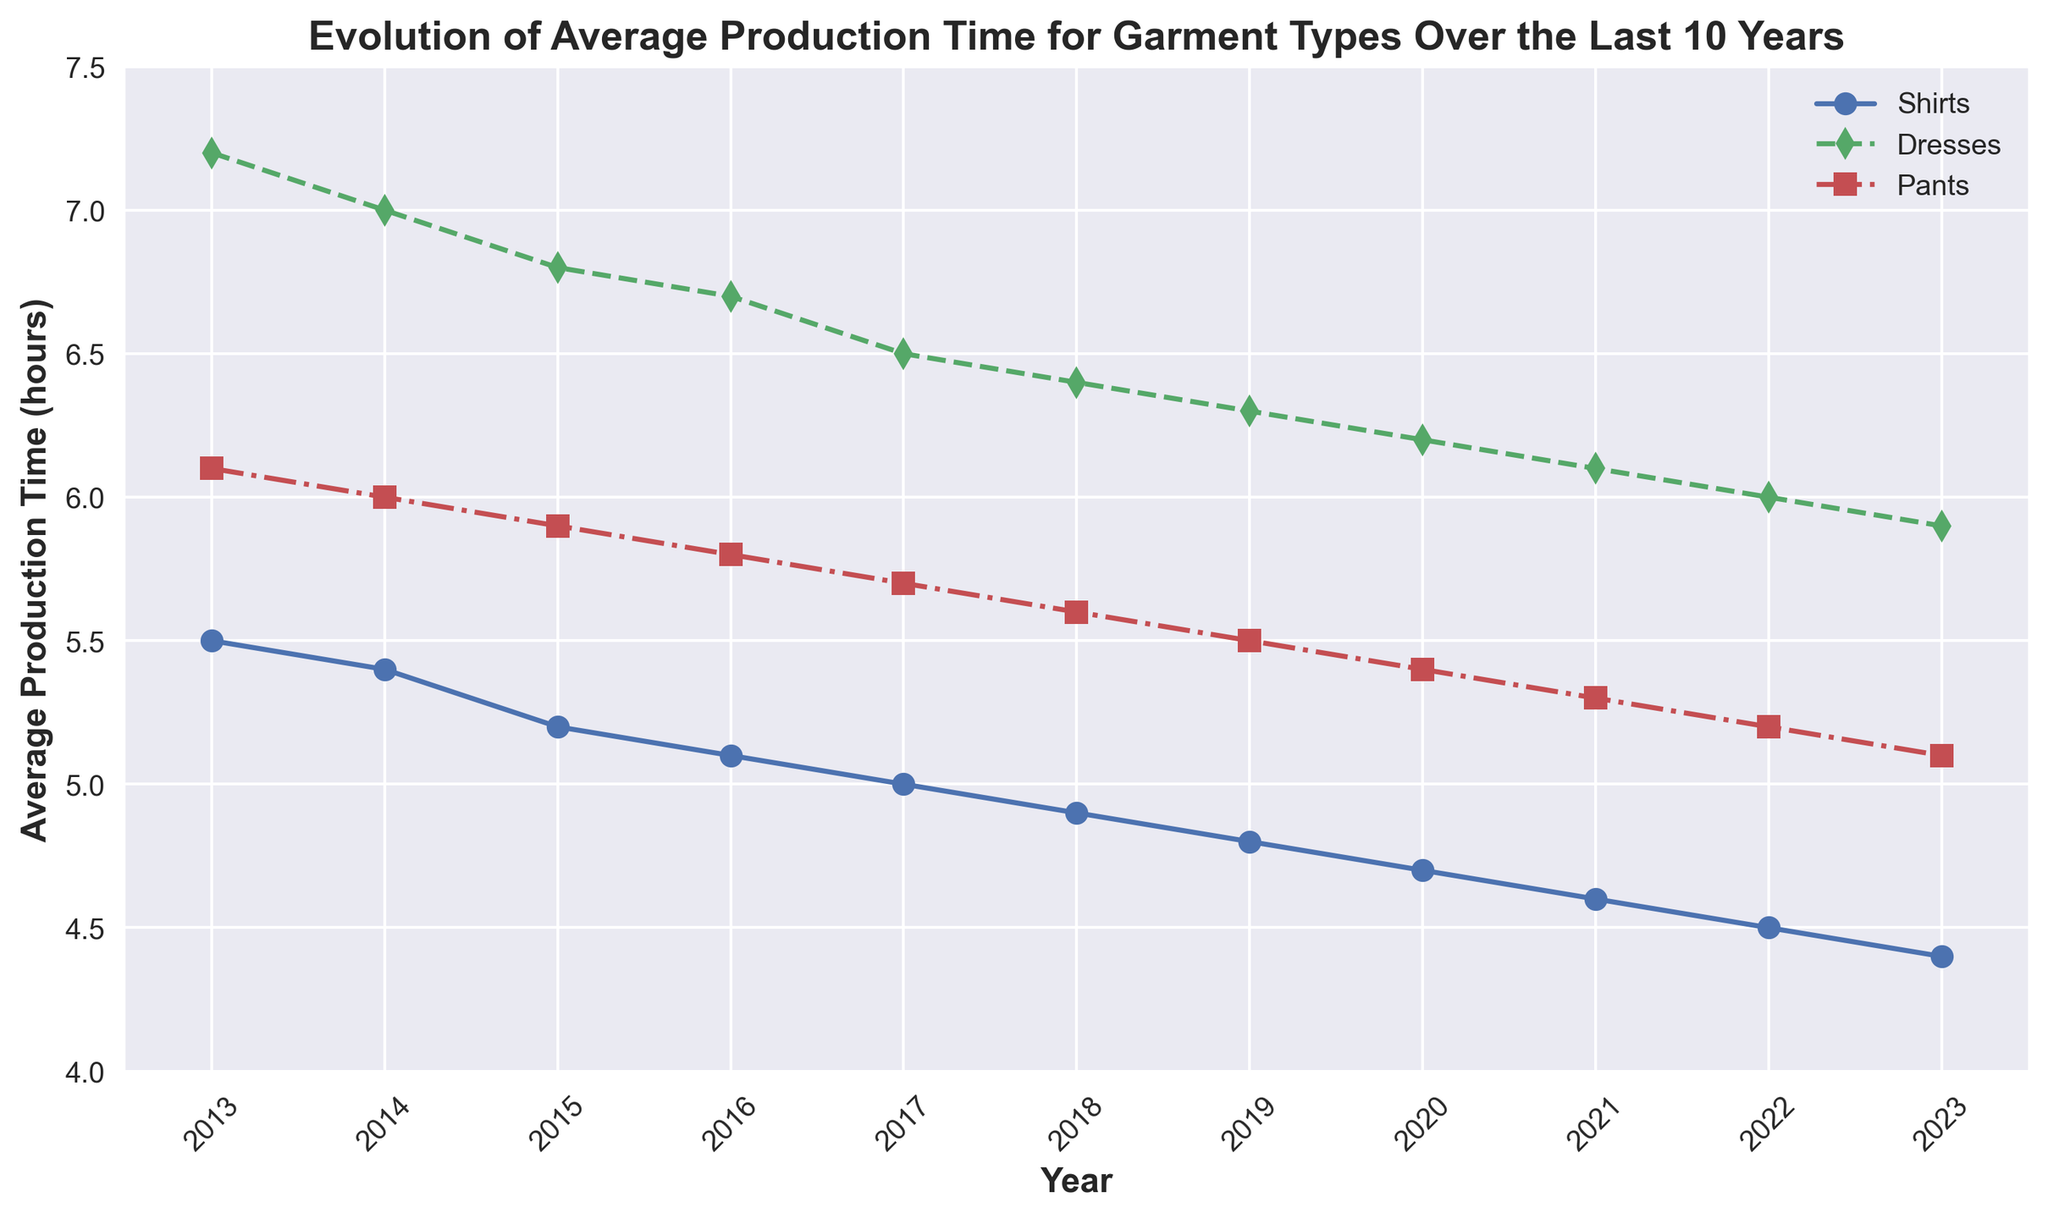What is the trend in the average production time for shirts over the last 10 years? The graph shows a downward trend for shirts' production time from 5.5 hours in 2013 to 4.4 hours in 2023. This indicates an overall decrease in production time over the period.
Answer: Decreasing How does the production time for dresses in 2023 compare to that for pants in 2021? The production time for dresses in 2023 is 5.9 hours, while for pants in 2021, it is 5.3 hours. Since 5.9 is greater than 5.3, the production time for dresses in 2023 is higher.
Answer: Dresses in 2023 are higher What is the difference in production times between pants in 2015 and pants in 2023? In 2015, the production time for pants was 5.9 hours, and in 2023, it was 5.1 hours. The difference is 5.9 - 5.1 = 0.8 hours.
Answer: 0.8 hours Which garment type had the highest average production time in 2017? The graph shows that in 2017, dresses had the highest production time at 6.5 hours, compared to shirts at 5.0 hours and pants at 5.7 hours.
Answer: Dresses What were the production times for all garment types in 2022, and which type had the lowest? In 2022, the production times were 4.5 hours for shirts, 6.0 hours for dresses, and 5.2 hours for pants. Shirts had the lowest production time.
Answer: Shirts By how much did the production time for dresses decrease from 2013 to 2020? The production time for dresses in 2013 was 7.2 hours and in 2020 it was 6.2 hours. The decrease is 7.2 - 6.2 = 1.0 hours.
Answer: 1.0 hours What visual differences exist in the line styles for shirts, dresses, and pants? The line for shirts uses a solid line with circular markers, dresses use a dashed line with diamond markers, and pants use a dash-dot line with square markers.
Answer: Shirts: solid with circles, Dresses: dashed with diamonds, Pants: dash-dot with squares How did the production time for pants change from 2019 to 2023? The production time for pants decreased from 5.5 hours in 2019 to 5.1 hours in 2023.
Answer: Decreased Calculate the average production time for shirts over the last 10 years. Summing the production times for shirts from 2013 to 2023: 5.5 + 5.4 + 5.2 + 5.1 + 5.0 + 4.9 + 4.8 + 4.7 + 4.6 + 4.5 + 4.4 = 49.1. Dividing by 11 years gives 49.1 / 11 = 4.46 hours.
Answer: 4.46 hours Which year had the smallest difference in production time between shirts and pants? Subtracting pants' time from shirts' time for each year: 2013: -0.6, 2014: -0.6, 2015: -0.7, 2016: -0.7, 2017: -0.7, 2018: -0.7, 2019: -0.7, 2020: -0.7, 2021: -0.7, 2022: -0.7, 2023: -0.7. The smallest difference is in 2013 and 2014 with -0.6 hours.
Answer: 2013 and 2014 